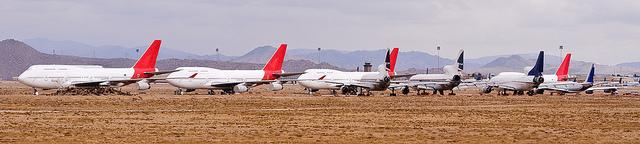What is the main factor keeping the planes on the dirt? Please explain your reasoning. age. These planes appear to be de-commissioned and not flying on a regular basis.  the biggest reason they are grounded is probably due to their age. 